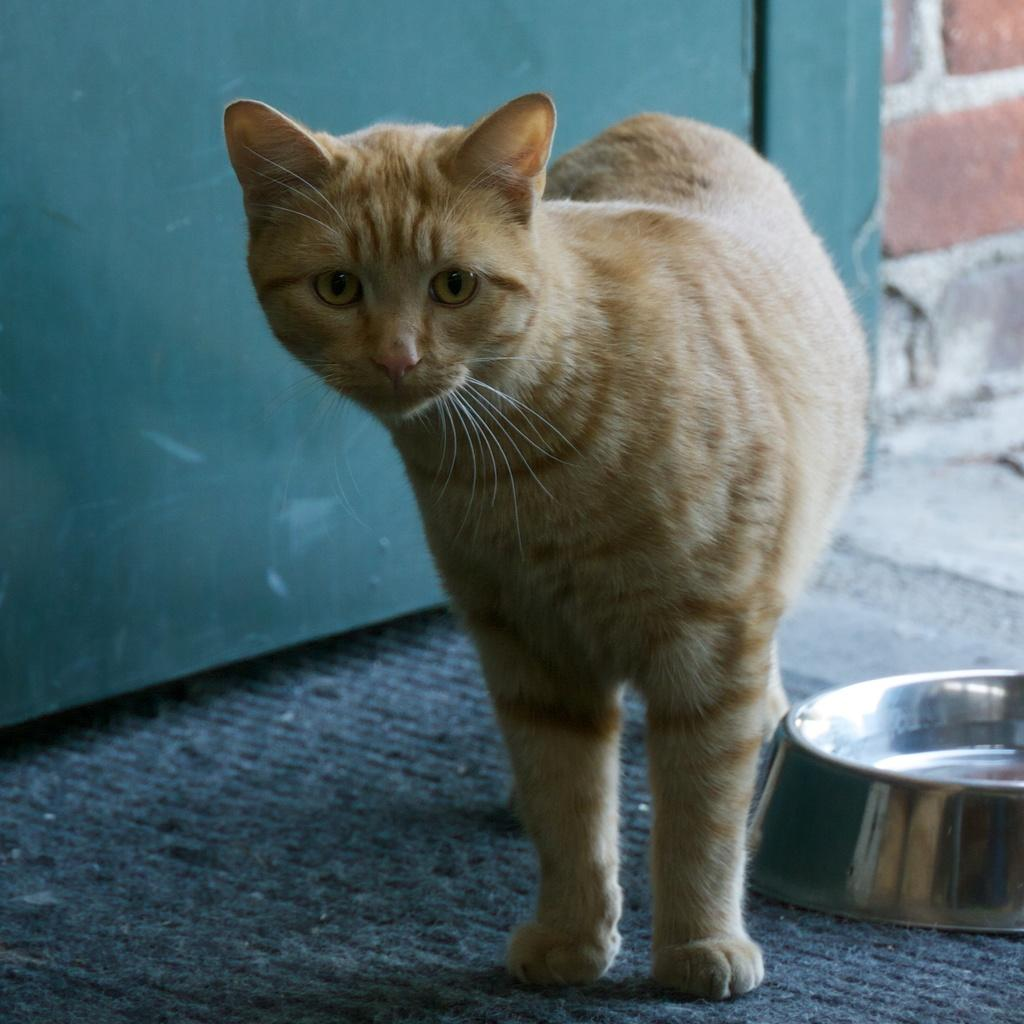What type of animal can be seen in the image? There is a cat in the image. What is visible beneath the cat's feet? The ground is visible in the image. What object can be seen on the right side of the image? There is a container on the right side of the image. What can be seen in the background of the image? There is a wall in the background of the image. What color is the object in the background of the image? There is a green colored object in the background of the image. What type of skirt can be seen in the image? There is no skirt present in the image. 